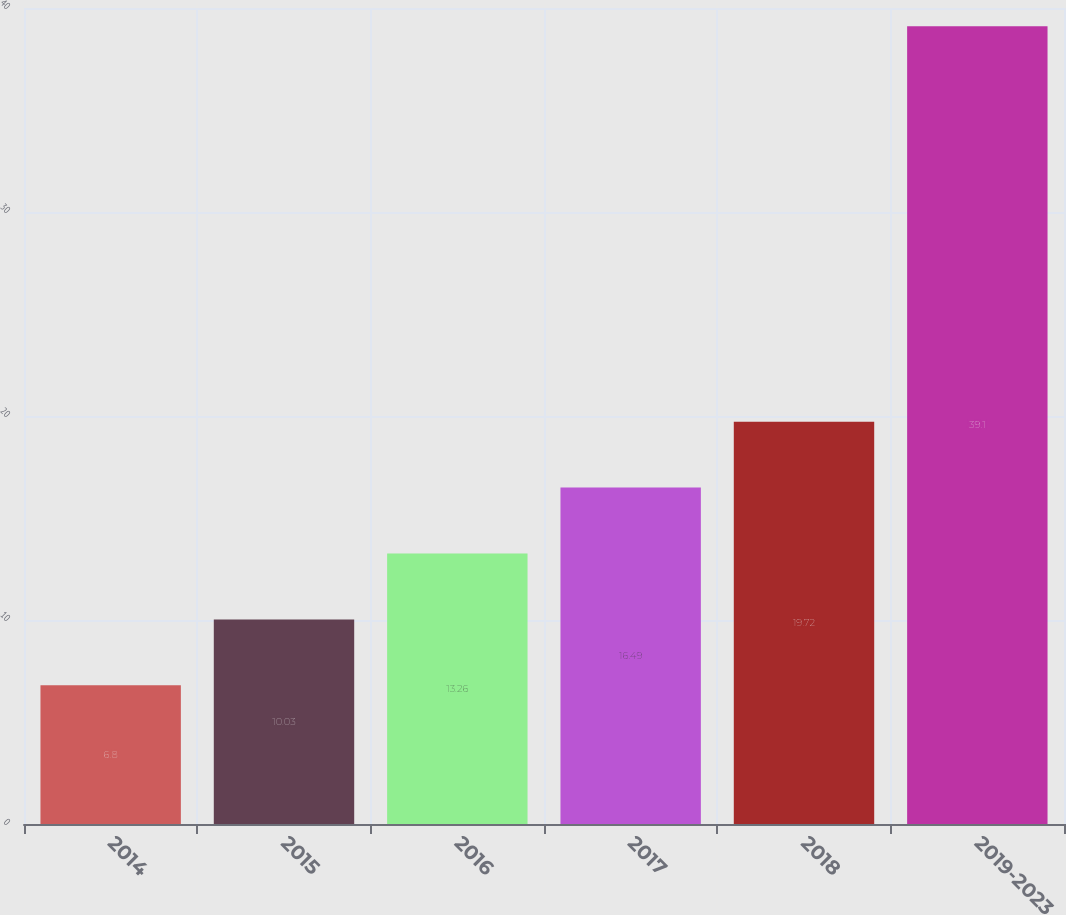Convert chart to OTSL. <chart><loc_0><loc_0><loc_500><loc_500><bar_chart><fcel>2014<fcel>2015<fcel>2016<fcel>2017<fcel>2018<fcel>2019-2023<nl><fcel>6.8<fcel>10.03<fcel>13.26<fcel>16.49<fcel>19.72<fcel>39.1<nl></chart> 